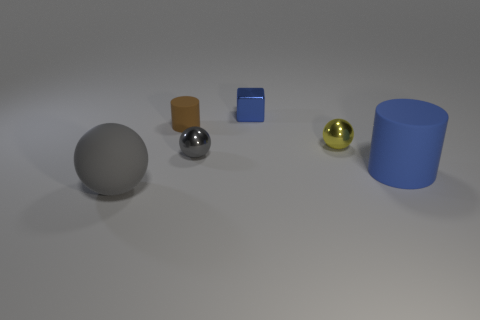What number of green rubber cylinders are the same size as the yellow thing?
Offer a very short reply. 0. What material is the large thing that is the same color as the metal cube?
Provide a short and direct response. Rubber. Does the blue thing that is left of the yellow shiny ball have the same shape as the small gray thing?
Make the answer very short. No. Is the number of tiny balls that are in front of the big gray rubber ball less than the number of large blue rubber things?
Make the answer very short. Yes. Is there a tiny object of the same color as the large rubber cylinder?
Give a very brief answer. Yes. There is a blue matte thing; does it have the same shape as the gray object that is behind the gray matte thing?
Provide a succinct answer. No. Is there a small cube that has the same material as the yellow object?
Provide a short and direct response. Yes. There is a small ball that is to the right of the gray ball behind the gray matte ball; are there any gray objects behind it?
Offer a terse response. No. How many other objects are there of the same shape as the small brown rubber thing?
Keep it short and to the point. 1. What color is the big object left of the cylinder on the right side of the blue thing that is behind the yellow object?
Provide a succinct answer. Gray. 